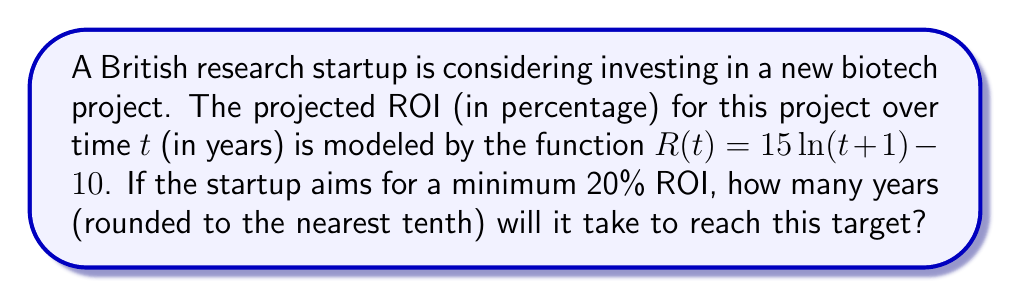Could you help me with this problem? Let's approach this step-by-step:

1) We need to find t when R(t) = 20%, as this is our target ROI.

2) Set up the equation:
   $20 = 15 \ln(t+1) - 10$

3) Add 10 to both sides:
   $30 = 15 \ln(t+1)$

4) Divide both sides by 15:
   $2 = \ln(t+1)$

5) Apply $e^x$ to both sides to remove the natural logarithm:
   $e^2 = e^{\ln(t+1)}$

6) Simplify the right side:
   $e^2 = t+1$

7) Subtract 1 from both sides:
   $e^2 - 1 = t$

8) Calculate $e^2$ and subtract 1:
   $t \approx 6.389$

9) Round to the nearest tenth:
   $t \approx 6.4$

Therefore, it will take approximately 6.4 years to reach a 20% ROI.
Answer: 6.4 years 